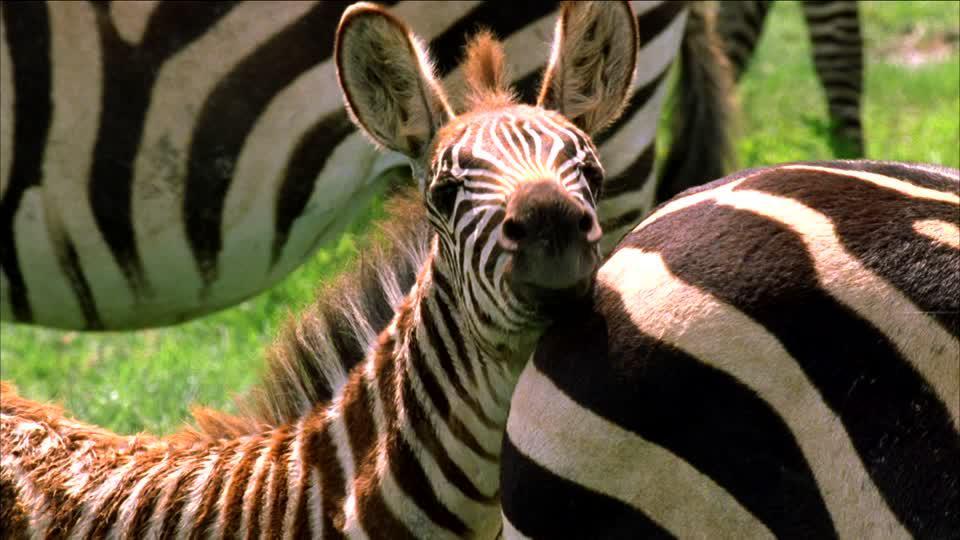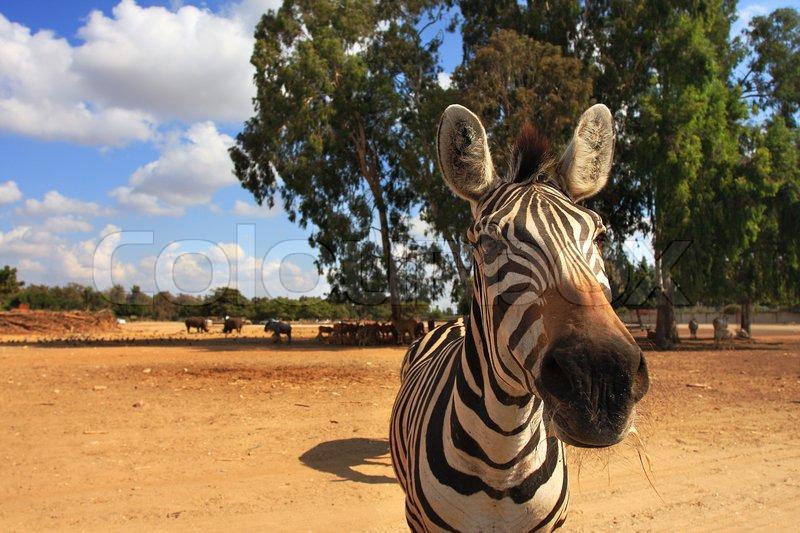The first image is the image on the left, the second image is the image on the right. Given the left and right images, does the statement "There are two zebras and blue sky visible in the left image." hold true? Answer yes or no. No. The first image is the image on the left, the second image is the image on the right. Assess this claim about the two images: "One image contains exactly two zebras facing opposite directions with heads that do not overlap, and the other image features one prominent zebra standing with its head upright.". Correct or not? Answer yes or no. No. 